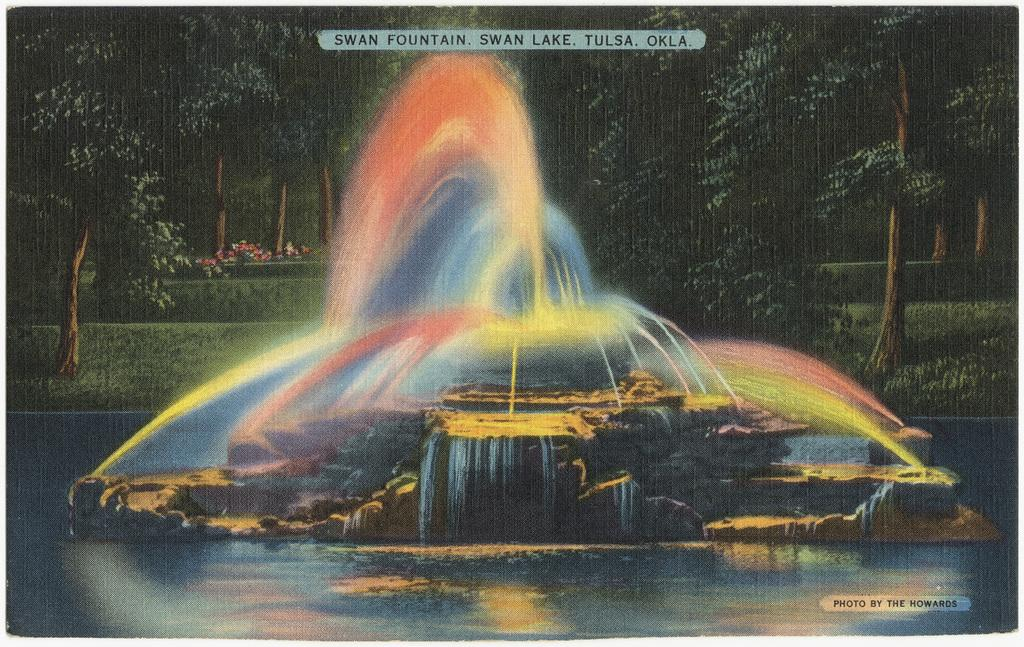What is the main feature in the image? There is a colorful water fountain in the image. What can be seen in the background of the image? There are trees, grass, and plants in the background of the image. Are there any water-related elements in the image? Yes, there is a water fountain and possibly watermarks in the image. What type of toothbrush is being used to clean the water fountain in the image? There is no toothbrush present in the image, and the water fountain is not being cleaned. What kind of meal is being served near the water fountain in the image? There is no meal present in the image; it primarily features a colorful water fountain and background elements. 